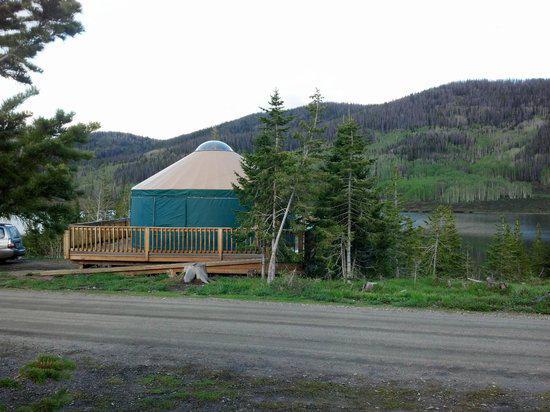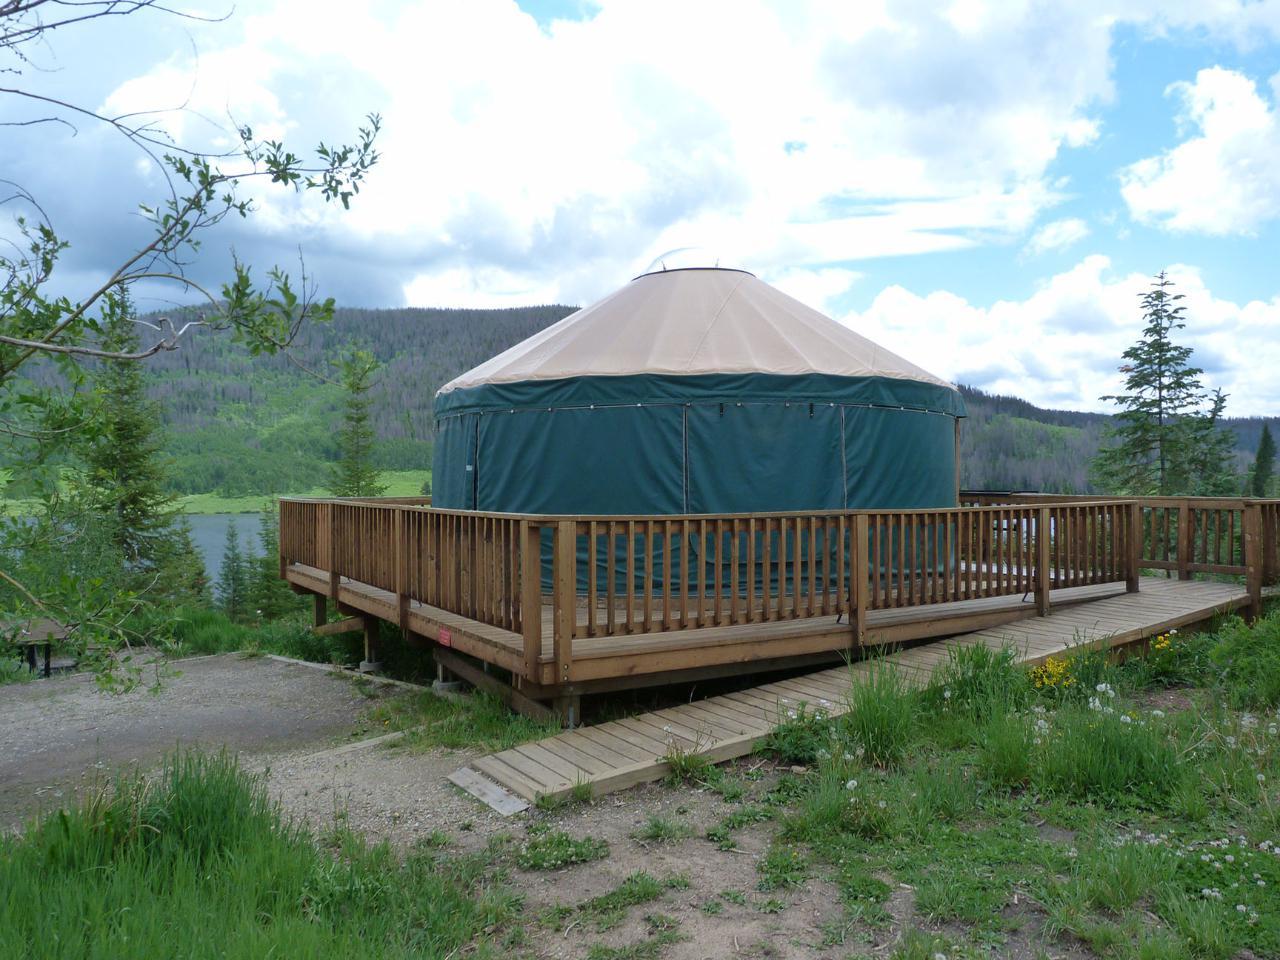The first image is the image on the left, the second image is the image on the right. Analyze the images presented: Is the assertion "there is no fence around the yurt in the image on the right" valid? Answer yes or no. No. The first image is the image on the left, the second image is the image on the right. Given the left and right images, does the statement "Two green round houses have white roofs and sit on flat wooden platforms." hold true? Answer yes or no. Yes. 